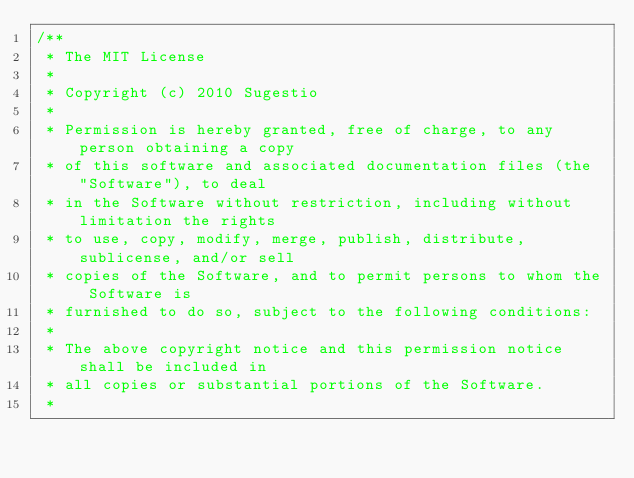Convert code to text. <code><loc_0><loc_0><loc_500><loc_500><_Java_>/**
 * The MIT License
 * 
 * Copyright (c) 2010 Sugestio
 * 
 * Permission is hereby granted, free of charge, to any person obtaining a copy
 * of this software and associated documentation files (the "Software"), to deal
 * in the Software without restriction, including without limitation the rights
 * to use, copy, modify, merge, publish, distribute, sublicense, and/or sell
 * copies of the Software, and to permit persons to whom the Software is
 * furnished to do so, subject to the following conditions:
 *
 * The above copyright notice and this permission notice shall be included in
 * all copies or substantial portions of the Software.
 *</code> 